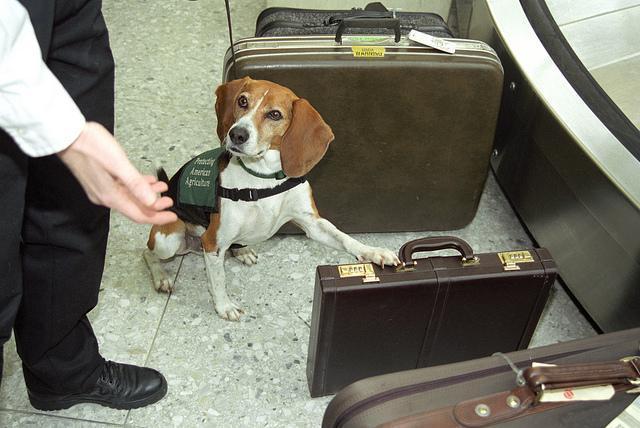How many dogs can you see?
Give a very brief answer. 1. How many suitcases are visible?
Give a very brief answer. 4. 